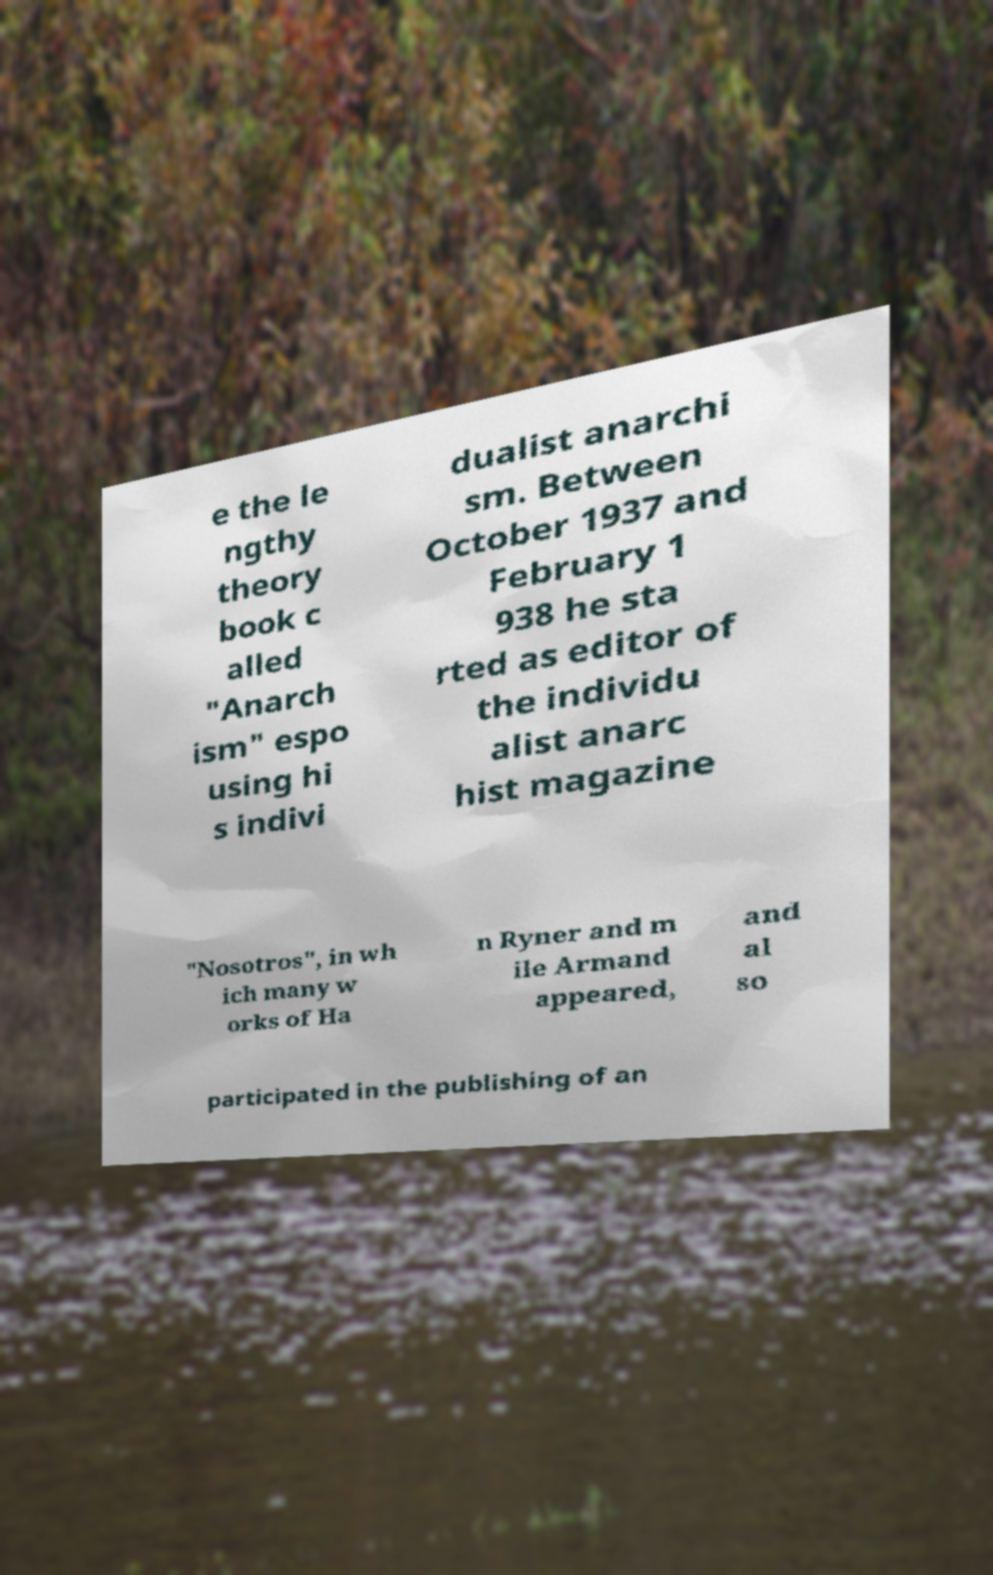Could you extract and type out the text from this image? e the le ngthy theory book c alled "Anarch ism" espo using hi s indivi dualist anarchi sm. Between October 1937 and February 1 938 he sta rted as editor of the individu alist anarc hist magazine "Nosotros", in wh ich many w orks of Ha n Ryner and m ile Armand appeared, and al so participated in the publishing of an 